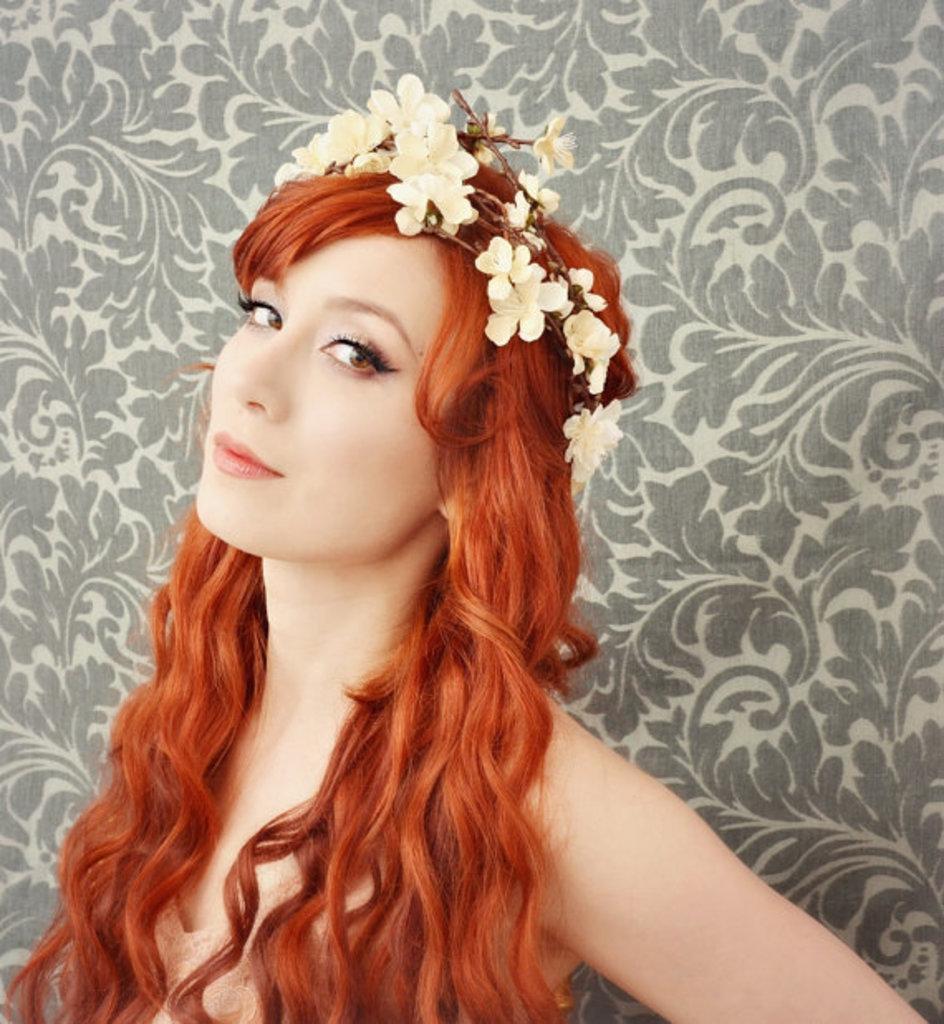Can you describe this image briefly? In this picture I can see there is a woman standing and she is wearing a flowered crown and in the backdrop I can see there is a decorated wall. 